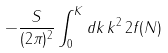<formula> <loc_0><loc_0><loc_500><loc_500>- \frac { S } { ( 2 \pi ) ^ { 2 } } \int _ { 0 } ^ { K } d k \, k ^ { 2 } \, 2 f ( N )</formula> 